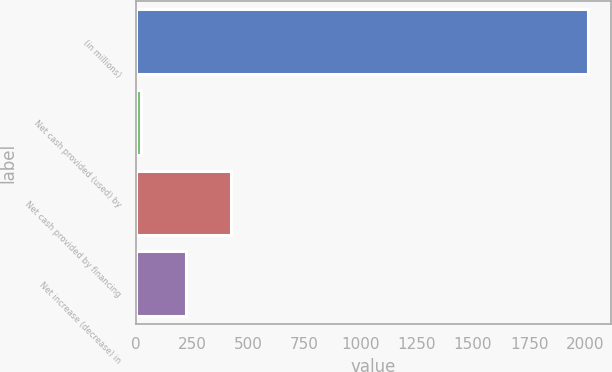Convert chart to OTSL. <chart><loc_0><loc_0><loc_500><loc_500><bar_chart><fcel>(in millions)<fcel>Net cash provided (used) by<fcel>Net cash provided by financing<fcel>Net increase (decrease) in<nl><fcel>2013<fcel>25<fcel>422.6<fcel>223.8<nl></chart> 